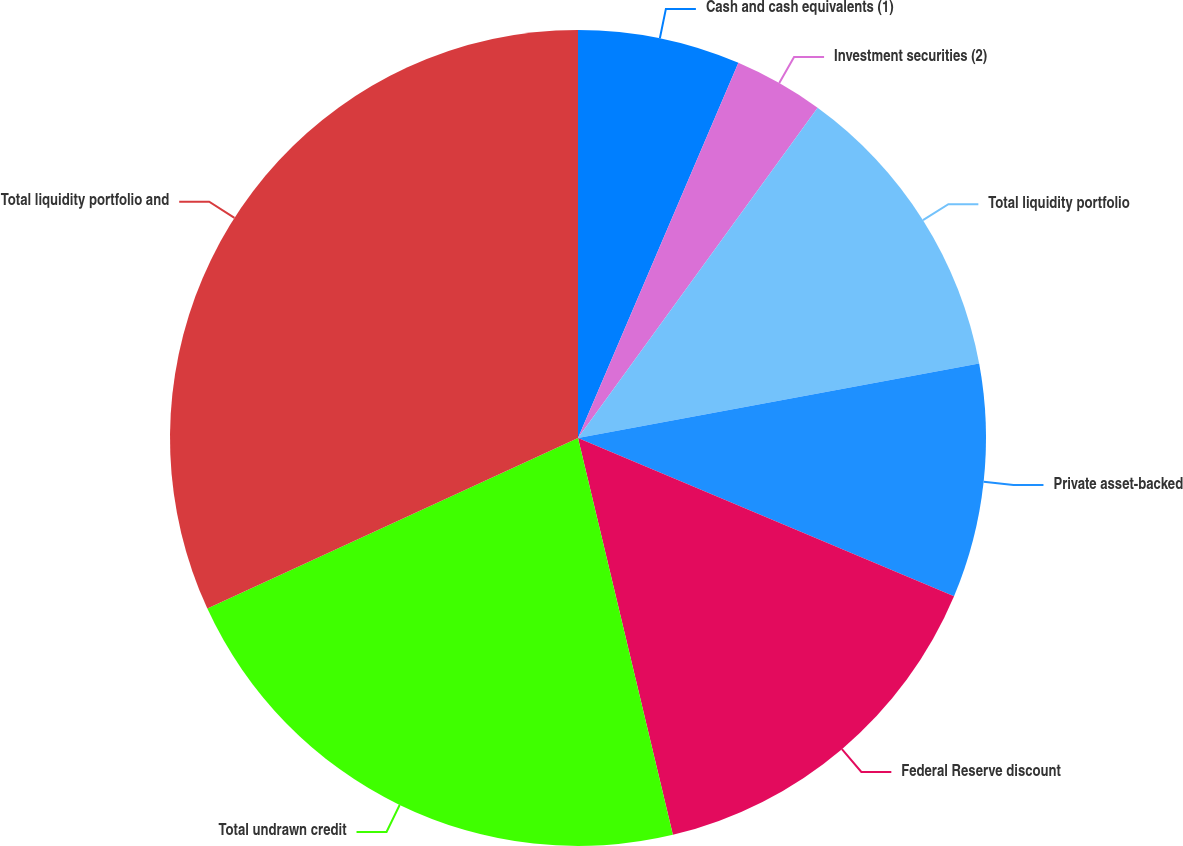<chart> <loc_0><loc_0><loc_500><loc_500><pie_chart><fcel>Cash and cash equivalents (1)<fcel>Investment securities (2)<fcel>Total liquidity portfolio<fcel>Private asset-backed<fcel>Federal Reserve discount<fcel>Total undrawn credit<fcel>Total liquidity portfolio and<nl><fcel>6.43%<fcel>3.56%<fcel>12.09%<fcel>9.26%<fcel>14.92%<fcel>21.87%<fcel>31.86%<nl></chart> 